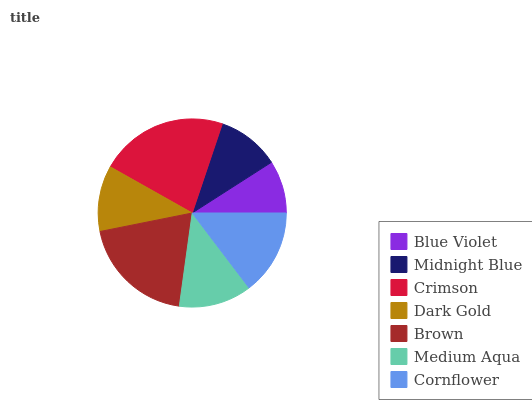Is Blue Violet the minimum?
Answer yes or no. Yes. Is Crimson the maximum?
Answer yes or no. Yes. Is Midnight Blue the minimum?
Answer yes or no. No. Is Midnight Blue the maximum?
Answer yes or no. No. Is Midnight Blue greater than Blue Violet?
Answer yes or no. Yes. Is Blue Violet less than Midnight Blue?
Answer yes or no. Yes. Is Blue Violet greater than Midnight Blue?
Answer yes or no. No. Is Midnight Blue less than Blue Violet?
Answer yes or no. No. Is Medium Aqua the high median?
Answer yes or no. Yes. Is Medium Aqua the low median?
Answer yes or no. Yes. Is Crimson the high median?
Answer yes or no. No. Is Blue Violet the low median?
Answer yes or no. No. 